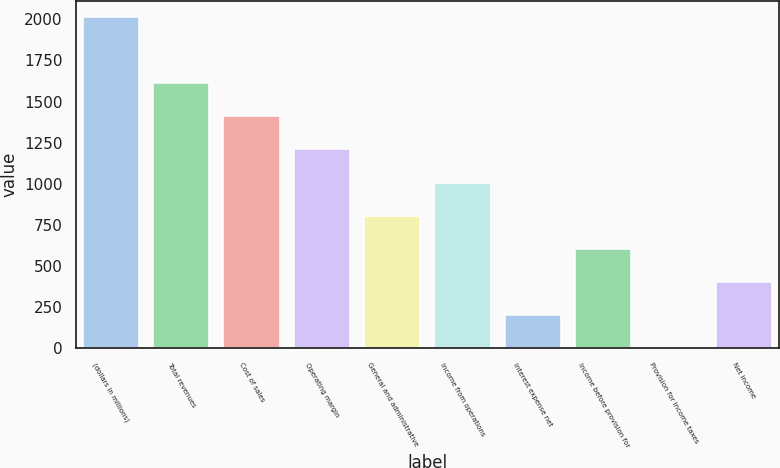Convert chart. <chart><loc_0><loc_0><loc_500><loc_500><bar_chart><fcel>(dollars in millions)<fcel>Total revenues<fcel>Cost of sales<fcel>Operating margin<fcel>General and administrative<fcel>Income from operations<fcel>Interest expense net<fcel>Income before provision for<fcel>Provision for income taxes<fcel>Net income<nl><fcel>2012<fcel>1610.42<fcel>1409.63<fcel>1208.84<fcel>807.26<fcel>1008.05<fcel>204.89<fcel>606.47<fcel>4.1<fcel>405.68<nl></chart> 